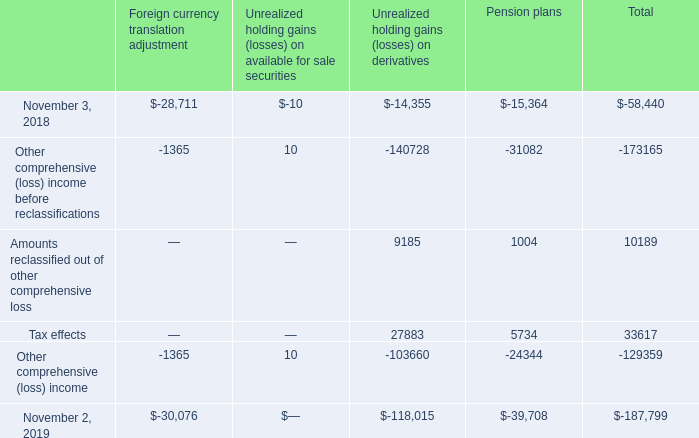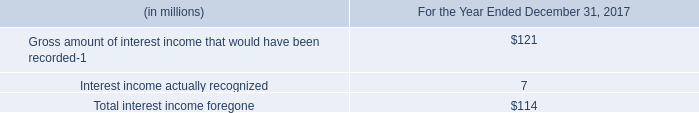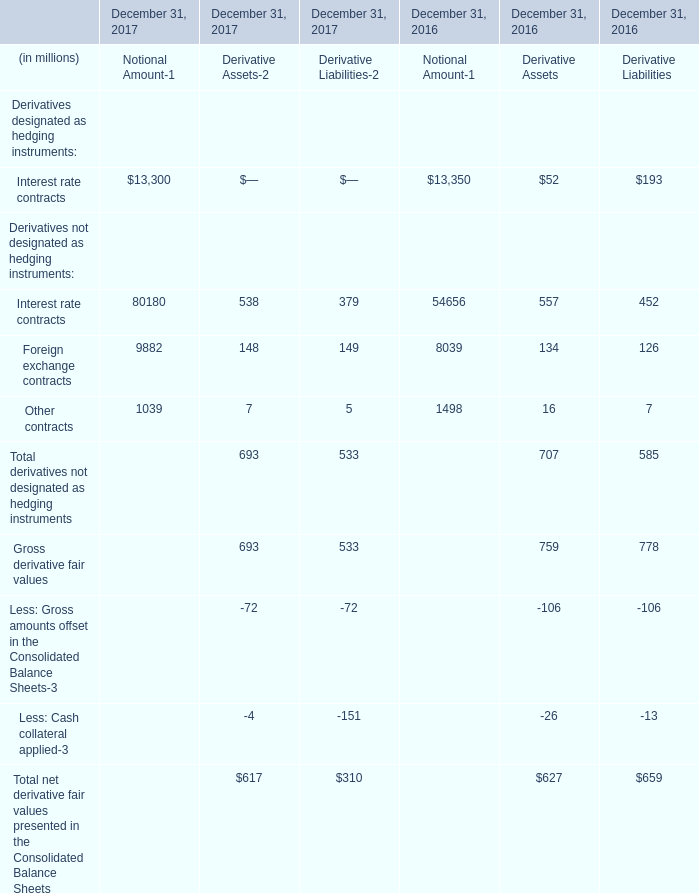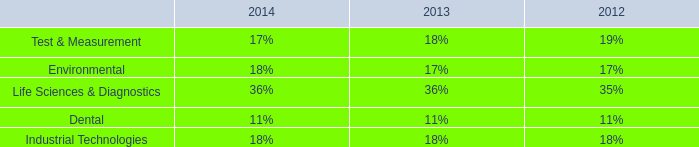what is the percentage change in the liability balance from 2018 to 2019? 
Computations: ((227.0 - 144.9) / 144.9)
Answer: 0.5666. 